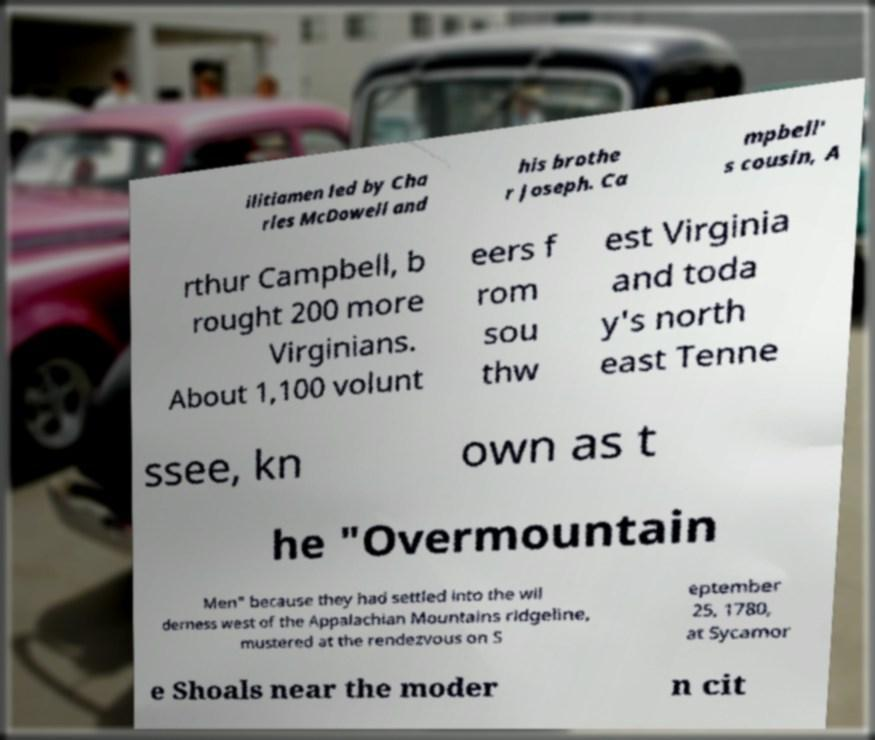Please identify and transcribe the text found in this image. ilitiamen led by Cha rles McDowell and his brothe r Joseph. Ca mpbell' s cousin, A rthur Campbell, b rought 200 more Virginians. About 1,100 volunt eers f rom sou thw est Virginia and toda y's north east Tenne ssee, kn own as t he "Overmountain Men" because they had settled into the wil derness west of the Appalachian Mountains ridgeline, mustered at the rendezvous on S eptember 25, 1780, at Sycamor e Shoals near the moder n cit 